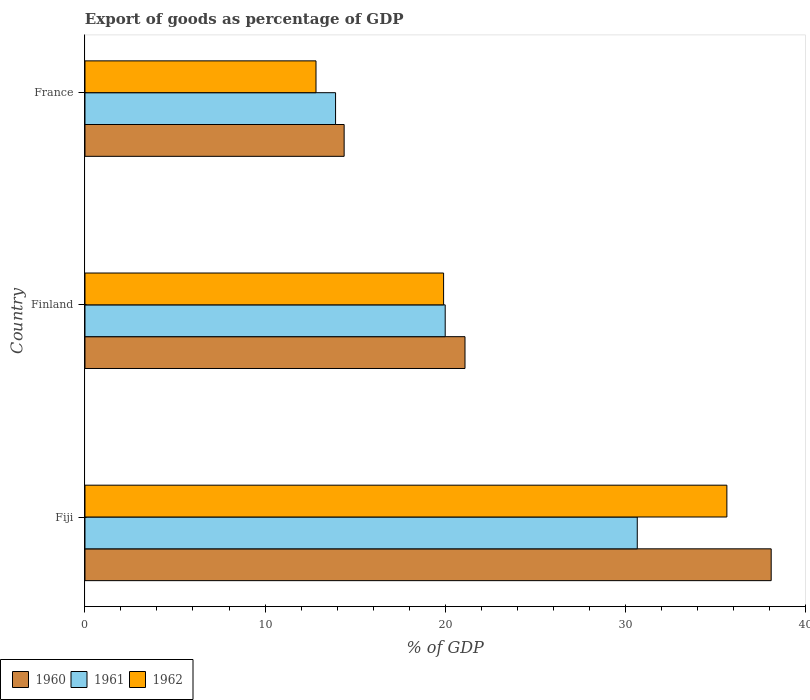How many different coloured bars are there?
Make the answer very short. 3. How many bars are there on the 2nd tick from the top?
Your answer should be very brief. 3. How many bars are there on the 1st tick from the bottom?
Offer a very short reply. 3. What is the label of the 1st group of bars from the top?
Give a very brief answer. France. In how many cases, is the number of bars for a given country not equal to the number of legend labels?
Offer a terse response. 0. What is the export of goods as percentage of GDP in 1962 in Fiji?
Your answer should be compact. 35.66. Across all countries, what is the maximum export of goods as percentage of GDP in 1961?
Offer a terse response. 30.68. Across all countries, what is the minimum export of goods as percentage of GDP in 1961?
Your answer should be compact. 13.92. In which country was the export of goods as percentage of GDP in 1961 maximum?
Offer a terse response. Fiji. What is the total export of goods as percentage of GDP in 1960 in the graph?
Your response must be concise. 73.62. What is the difference between the export of goods as percentage of GDP in 1962 in Fiji and that in Finland?
Give a very brief answer. 15.74. What is the difference between the export of goods as percentage of GDP in 1961 in Fiji and the export of goods as percentage of GDP in 1960 in France?
Ensure brevity in your answer.  16.28. What is the average export of goods as percentage of GDP in 1961 per country?
Your answer should be very brief. 21.54. What is the difference between the export of goods as percentage of GDP in 1961 and export of goods as percentage of GDP in 1962 in France?
Make the answer very short. 1.09. What is the ratio of the export of goods as percentage of GDP in 1961 in Fiji to that in Finland?
Your answer should be compact. 1.53. Is the difference between the export of goods as percentage of GDP in 1961 in Fiji and Finland greater than the difference between the export of goods as percentage of GDP in 1962 in Fiji and Finland?
Your answer should be very brief. No. What is the difference between the highest and the second highest export of goods as percentage of GDP in 1962?
Your answer should be very brief. 15.74. What is the difference between the highest and the lowest export of goods as percentage of GDP in 1960?
Provide a succinct answer. 23.72. What does the 2nd bar from the top in France represents?
Provide a succinct answer. 1961. Is it the case that in every country, the sum of the export of goods as percentage of GDP in 1962 and export of goods as percentage of GDP in 1961 is greater than the export of goods as percentage of GDP in 1960?
Your answer should be compact. Yes. Are all the bars in the graph horizontal?
Your answer should be compact. Yes. How many countries are there in the graph?
Your answer should be compact. 3. What is the difference between two consecutive major ticks on the X-axis?
Keep it short and to the point. 10. Are the values on the major ticks of X-axis written in scientific E-notation?
Your answer should be compact. No. Does the graph contain grids?
Make the answer very short. No. Where does the legend appear in the graph?
Make the answer very short. Bottom left. How many legend labels are there?
Make the answer very short. 3. What is the title of the graph?
Make the answer very short. Export of goods as percentage of GDP. Does "1963" appear as one of the legend labels in the graph?
Offer a very short reply. No. What is the label or title of the X-axis?
Offer a very short reply. % of GDP. What is the label or title of the Y-axis?
Provide a succinct answer. Country. What is the % of GDP of 1960 in Fiji?
Make the answer very short. 38.12. What is the % of GDP of 1961 in Fiji?
Make the answer very short. 30.68. What is the % of GDP in 1962 in Fiji?
Your answer should be compact. 35.66. What is the % of GDP of 1960 in Finland?
Provide a succinct answer. 21.11. What is the % of GDP in 1961 in Finland?
Provide a short and direct response. 20.01. What is the % of GDP of 1962 in Finland?
Offer a terse response. 19.92. What is the % of GDP of 1960 in France?
Your answer should be very brief. 14.4. What is the % of GDP of 1961 in France?
Your response must be concise. 13.92. What is the % of GDP in 1962 in France?
Your answer should be very brief. 12.83. Across all countries, what is the maximum % of GDP of 1960?
Your answer should be compact. 38.12. Across all countries, what is the maximum % of GDP in 1961?
Give a very brief answer. 30.68. Across all countries, what is the maximum % of GDP of 1962?
Give a very brief answer. 35.66. Across all countries, what is the minimum % of GDP in 1960?
Provide a succinct answer. 14.4. Across all countries, what is the minimum % of GDP of 1961?
Offer a very short reply. 13.92. Across all countries, what is the minimum % of GDP of 1962?
Offer a very short reply. 12.83. What is the total % of GDP in 1960 in the graph?
Provide a short and direct response. 73.62. What is the total % of GDP of 1961 in the graph?
Make the answer very short. 64.61. What is the total % of GDP of 1962 in the graph?
Give a very brief answer. 68.41. What is the difference between the % of GDP in 1960 in Fiji and that in Finland?
Provide a succinct answer. 17.01. What is the difference between the % of GDP of 1961 in Fiji and that in Finland?
Ensure brevity in your answer.  10.67. What is the difference between the % of GDP in 1962 in Fiji and that in Finland?
Make the answer very short. 15.74. What is the difference between the % of GDP of 1960 in Fiji and that in France?
Your answer should be very brief. 23.72. What is the difference between the % of GDP of 1961 in Fiji and that in France?
Keep it short and to the point. 16.76. What is the difference between the % of GDP in 1962 in Fiji and that in France?
Ensure brevity in your answer.  22.82. What is the difference between the % of GDP of 1960 in Finland and that in France?
Offer a terse response. 6.71. What is the difference between the % of GDP in 1961 in Finland and that in France?
Give a very brief answer. 6.09. What is the difference between the % of GDP of 1962 in Finland and that in France?
Offer a very short reply. 7.09. What is the difference between the % of GDP in 1960 in Fiji and the % of GDP in 1961 in Finland?
Offer a very short reply. 18.11. What is the difference between the % of GDP of 1960 in Fiji and the % of GDP of 1962 in Finland?
Give a very brief answer. 18.2. What is the difference between the % of GDP in 1961 in Fiji and the % of GDP in 1962 in Finland?
Ensure brevity in your answer.  10.76. What is the difference between the % of GDP in 1960 in Fiji and the % of GDP in 1961 in France?
Ensure brevity in your answer.  24.2. What is the difference between the % of GDP in 1960 in Fiji and the % of GDP in 1962 in France?
Provide a succinct answer. 25.28. What is the difference between the % of GDP of 1961 in Fiji and the % of GDP of 1962 in France?
Your answer should be very brief. 17.85. What is the difference between the % of GDP in 1960 in Finland and the % of GDP in 1961 in France?
Provide a short and direct response. 7.19. What is the difference between the % of GDP of 1960 in Finland and the % of GDP of 1962 in France?
Your answer should be compact. 8.28. What is the difference between the % of GDP of 1961 in Finland and the % of GDP of 1962 in France?
Your answer should be compact. 7.18. What is the average % of GDP of 1960 per country?
Your response must be concise. 24.54. What is the average % of GDP in 1961 per country?
Your answer should be compact. 21.54. What is the average % of GDP of 1962 per country?
Offer a very short reply. 22.8. What is the difference between the % of GDP of 1960 and % of GDP of 1961 in Fiji?
Your response must be concise. 7.44. What is the difference between the % of GDP of 1960 and % of GDP of 1962 in Fiji?
Keep it short and to the point. 2.46. What is the difference between the % of GDP of 1961 and % of GDP of 1962 in Fiji?
Your answer should be very brief. -4.98. What is the difference between the % of GDP of 1960 and % of GDP of 1961 in Finland?
Your answer should be compact. 1.1. What is the difference between the % of GDP of 1960 and % of GDP of 1962 in Finland?
Provide a succinct answer. 1.19. What is the difference between the % of GDP of 1961 and % of GDP of 1962 in Finland?
Your response must be concise. 0.09. What is the difference between the % of GDP in 1960 and % of GDP in 1961 in France?
Your response must be concise. 0.48. What is the difference between the % of GDP of 1960 and % of GDP of 1962 in France?
Your response must be concise. 1.56. What is the difference between the % of GDP in 1961 and % of GDP in 1962 in France?
Your answer should be very brief. 1.09. What is the ratio of the % of GDP in 1960 in Fiji to that in Finland?
Ensure brevity in your answer.  1.81. What is the ratio of the % of GDP in 1961 in Fiji to that in Finland?
Your answer should be very brief. 1.53. What is the ratio of the % of GDP of 1962 in Fiji to that in Finland?
Make the answer very short. 1.79. What is the ratio of the % of GDP of 1960 in Fiji to that in France?
Make the answer very short. 2.65. What is the ratio of the % of GDP in 1961 in Fiji to that in France?
Provide a short and direct response. 2.2. What is the ratio of the % of GDP of 1962 in Fiji to that in France?
Provide a short and direct response. 2.78. What is the ratio of the % of GDP in 1960 in Finland to that in France?
Offer a terse response. 1.47. What is the ratio of the % of GDP of 1961 in Finland to that in France?
Provide a short and direct response. 1.44. What is the ratio of the % of GDP of 1962 in Finland to that in France?
Provide a succinct answer. 1.55. What is the difference between the highest and the second highest % of GDP of 1960?
Provide a succinct answer. 17.01. What is the difference between the highest and the second highest % of GDP of 1961?
Your response must be concise. 10.67. What is the difference between the highest and the second highest % of GDP in 1962?
Give a very brief answer. 15.74. What is the difference between the highest and the lowest % of GDP in 1960?
Keep it short and to the point. 23.72. What is the difference between the highest and the lowest % of GDP of 1961?
Your response must be concise. 16.76. What is the difference between the highest and the lowest % of GDP in 1962?
Offer a very short reply. 22.82. 